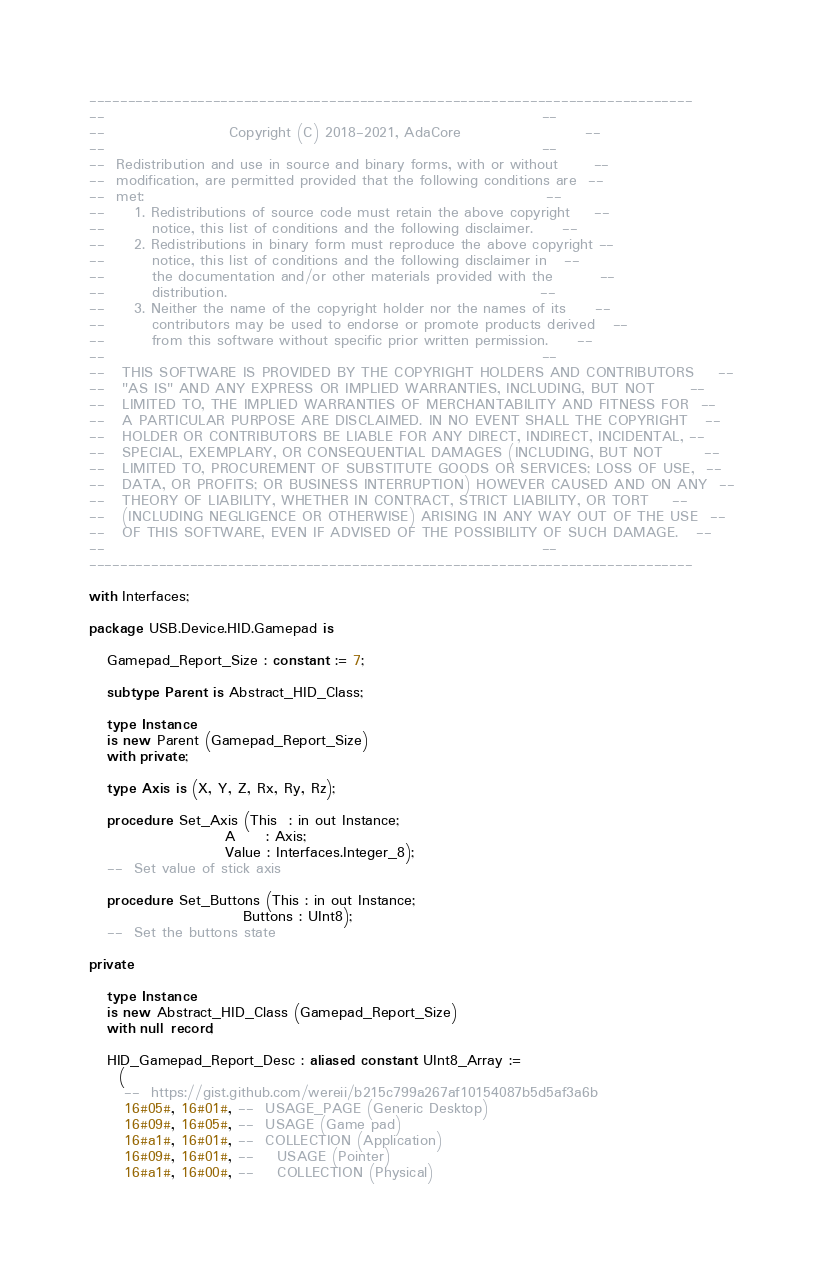Convert code to text. <code><loc_0><loc_0><loc_500><loc_500><_Ada_>------------------------------------------------------------------------------
--                                                                          --
--                     Copyright (C) 2018-2021, AdaCore                     --
--                                                                          --
--  Redistribution and use in source and binary forms, with or without      --
--  modification, are permitted provided that the following conditions are  --
--  met:                                                                    --
--     1. Redistributions of source code must retain the above copyright    --
--        notice, this list of conditions and the following disclaimer.     --
--     2. Redistributions in binary form must reproduce the above copyright --
--        notice, this list of conditions and the following disclaimer in   --
--        the documentation and/or other materials provided with the        --
--        distribution.                                                     --
--     3. Neither the name of the copyright holder nor the names of its     --
--        contributors may be used to endorse or promote products derived   --
--        from this software without specific prior written permission.     --
--                                                                          --
--   THIS SOFTWARE IS PROVIDED BY THE COPYRIGHT HOLDERS AND CONTRIBUTORS    --
--   "AS IS" AND ANY EXPRESS OR IMPLIED WARRANTIES, INCLUDING, BUT NOT      --
--   LIMITED TO, THE IMPLIED WARRANTIES OF MERCHANTABILITY AND FITNESS FOR  --
--   A PARTICULAR PURPOSE ARE DISCLAIMED. IN NO EVENT SHALL THE COPYRIGHT   --
--   HOLDER OR CONTRIBUTORS BE LIABLE FOR ANY DIRECT, INDIRECT, INCIDENTAL, --
--   SPECIAL, EXEMPLARY, OR CONSEQUENTIAL DAMAGES (INCLUDING, BUT NOT       --
--   LIMITED TO, PROCUREMENT OF SUBSTITUTE GOODS OR SERVICES; LOSS OF USE,  --
--   DATA, OR PROFITS; OR BUSINESS INTERRUPTION) HOWEVER CAUSED AND ON ANY  --
--   THEORY OF LIABILITY, WHETHER IN CONTRACT, STRICT LIABILITY, OR TORT    --
--   (INCLUDING NEGLIGENCE OR OTHERWISE) ARISING IN ANY WAY OUT OF THE USE  --
--   OF THIS SOFTWARE, EVEN IF ADVISED OF THE POSSIBILITY OF SUCH DAMAGE.   --
--                                                                          --
------------------------------------------------------------------------------

with Interfaces;

package USB.Device.HID.Gamepad is

   Gamepad_Report_Size : constant := 7;

   subtype Parent is Abstract_HID_Class;

   type Instance
   is new Parent (Gamepad_Report_Size)
   with private;

   type Axis is (X, Y, Z, Rx, Ry, Rz);

   procedure Set_Axis (This  : in out Instance;
                       A     : Axis;
                       Value : Interfaces.Integer_8);
   --  Set value of stick axis

   procedure Set_Buttons (This : in out Instance;
                          Buttons : UInt8);
   --  Set the buttons state

private

   type Instance
   is new Abstract_HID_Class (Gamepad_Report_Size)
   with null record;

   HID_Gamepad_Report_Desc : aliased constant UInt8_Array :=
     (
      --  https://gist.github.com/wereii/b215c799a267af10154087b5d5af3a6b
      16#05#, 16#01#, --  USAGE_PAGE (Generic Desktop)
      16#09#, 16#05#, --  USAGE (Game pad)
      16#a1#, 16#01#, --  COLLECTION (Application)
      16#09#, 16#01#, --    USAGE (Pointer)
      16#a1#, 16#00#, --    COLLECTION (Physical)
</code> 